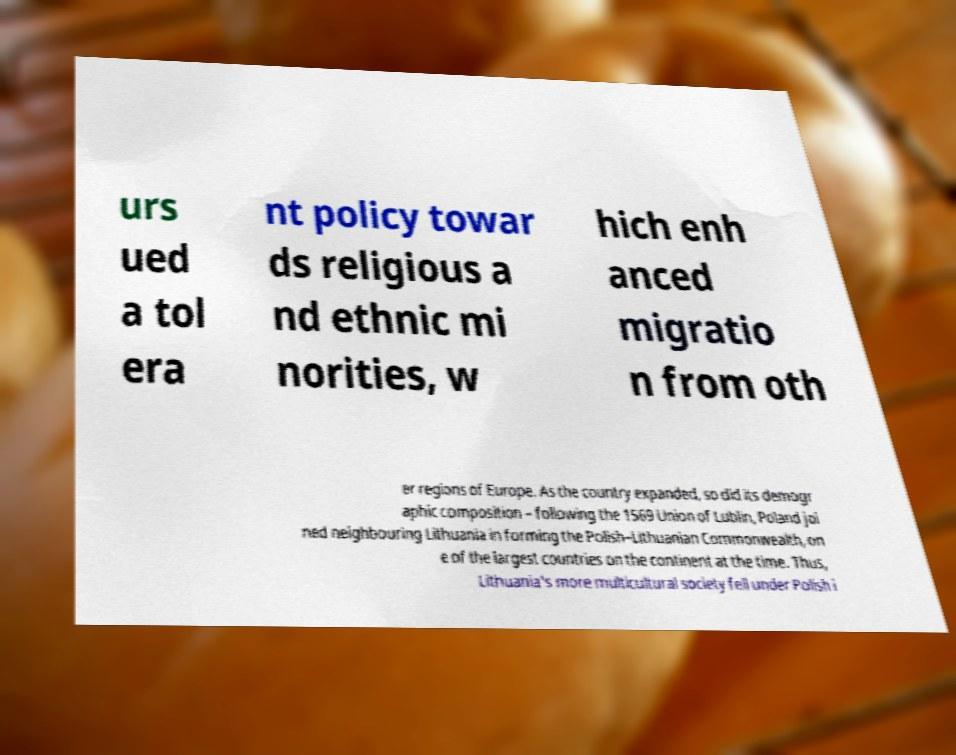For documentation purposes, I need the text within this image transcribed. Could you provide that? urs ued a tol era nt policy towar ds religious a nd ethnic mi norities, w hich enh anced migratio n from oth er regions of Europe. As the country expanded, so did its demogr aphic composition – following the 1569 Union of Lublin, Poland joi ned neighbouring Lithuania in forming the Polish–Lithuanian Commonwealth, on e of the largest countries on the continent at the time. Thus, Lithuania's more multicultural society fell under Polish i 